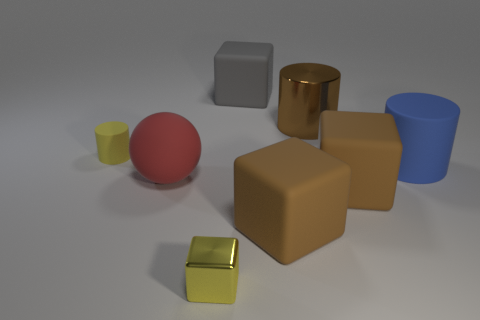Add 1 brown metal cylinders. How many objects exist? 9 Subtract all cylinders. How many objects are left? 5 Add 2 cylinders. How many cylinders exist? 5 Subtract 0 blue blocks. How many objects are left? 8 Subtract all metallic cylinders. Subtract all tiny rubber objects. How many objects are left? 6 Add 1 tiny cylinders. How many tiny cylinders are left? 2 